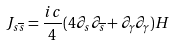Convert formula to latex. <formula><loc_0><loc_0><loc_500><loc_500>J _ { s \overline { s } } = \frac { i c } { 4 } ( 4 \partial _ { s } \partial _ { \overline { s } } + \partial _ { \gamma } \partial _ { \gamma } ) H</formula> 